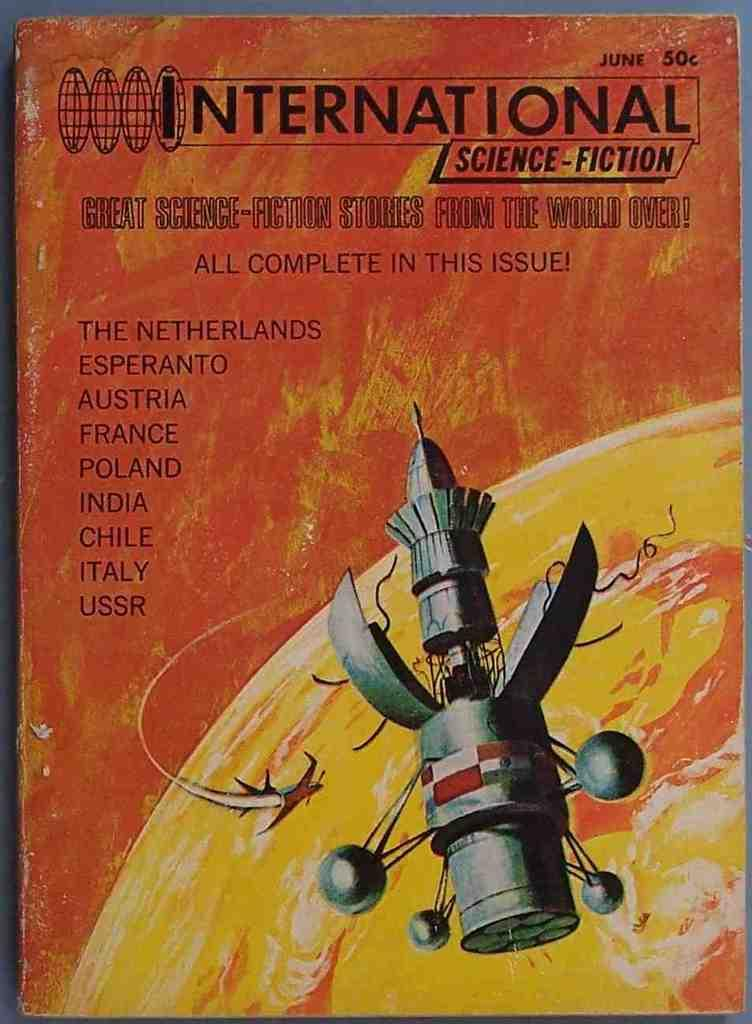What is the main object in the image? There is a book in the image. What is depicted above the book? There is an animated picture of a rocket above the book. What can be found on the book itself? There is text written on the book. How does the finger interact with the friction in the image? There is no finger or friction present in the image. What message is conveyed in the image when saying good-bye? The image does not convey any message related to saying good-bye; it features a book with an animated picture of a rocket and text. 